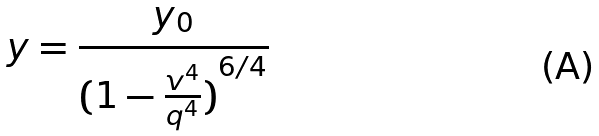Convert formula to latex. <formula><loc_0><loc_0><loc_500><loc_500>y = \frac { y _ { 0 } } { ( { 1 - \frac { v ^ { 4 } } { q ^ { 4 } } ) } ^ { 6 / 4 } }</formula> 